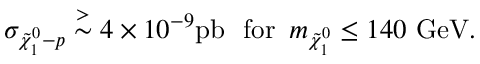<formula> <loc_0><loc_0><loc_500><loc_500>\sigma _ { \tilde { \chi } _ { 1 } ^ { 0 } - p } \stackrel { > } { \sim } 4 \times 1 0 ^ { - 9 } p b \, f o r \, m _ { \tilde { \chi } _ { 1 } ^ { 0 } } \leq 1 4 0 G e V .</formula> 